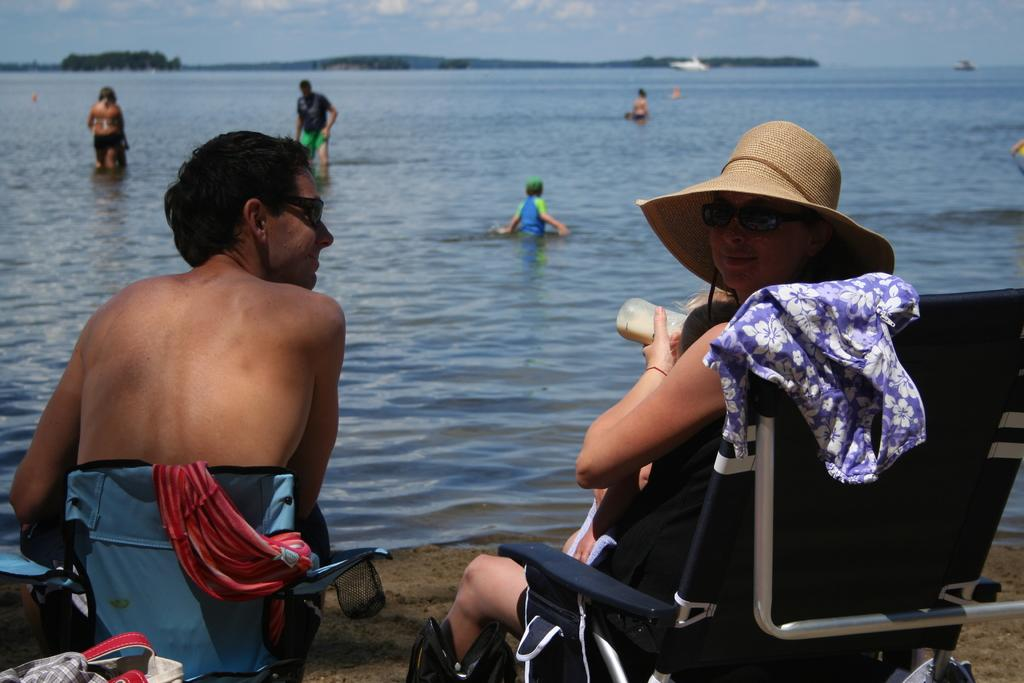What is the woman in the image doing? The woman is sitting on a chair in the image. What is the woman wearing on her head? The woman is wearing a hat. What can be seen happening in the water in the image? There are people in the water in the image. What is visible at the top of the image? The sky is visible at the top of the image. What type of cake is being served at the event in the image? There is no event or cake present in the image; it features a woman sitting on a chair and people in the water. What is the reason for the woman wearing a hat in the image? There is no information provided about the reason for the woman wearing a hat in the image. 